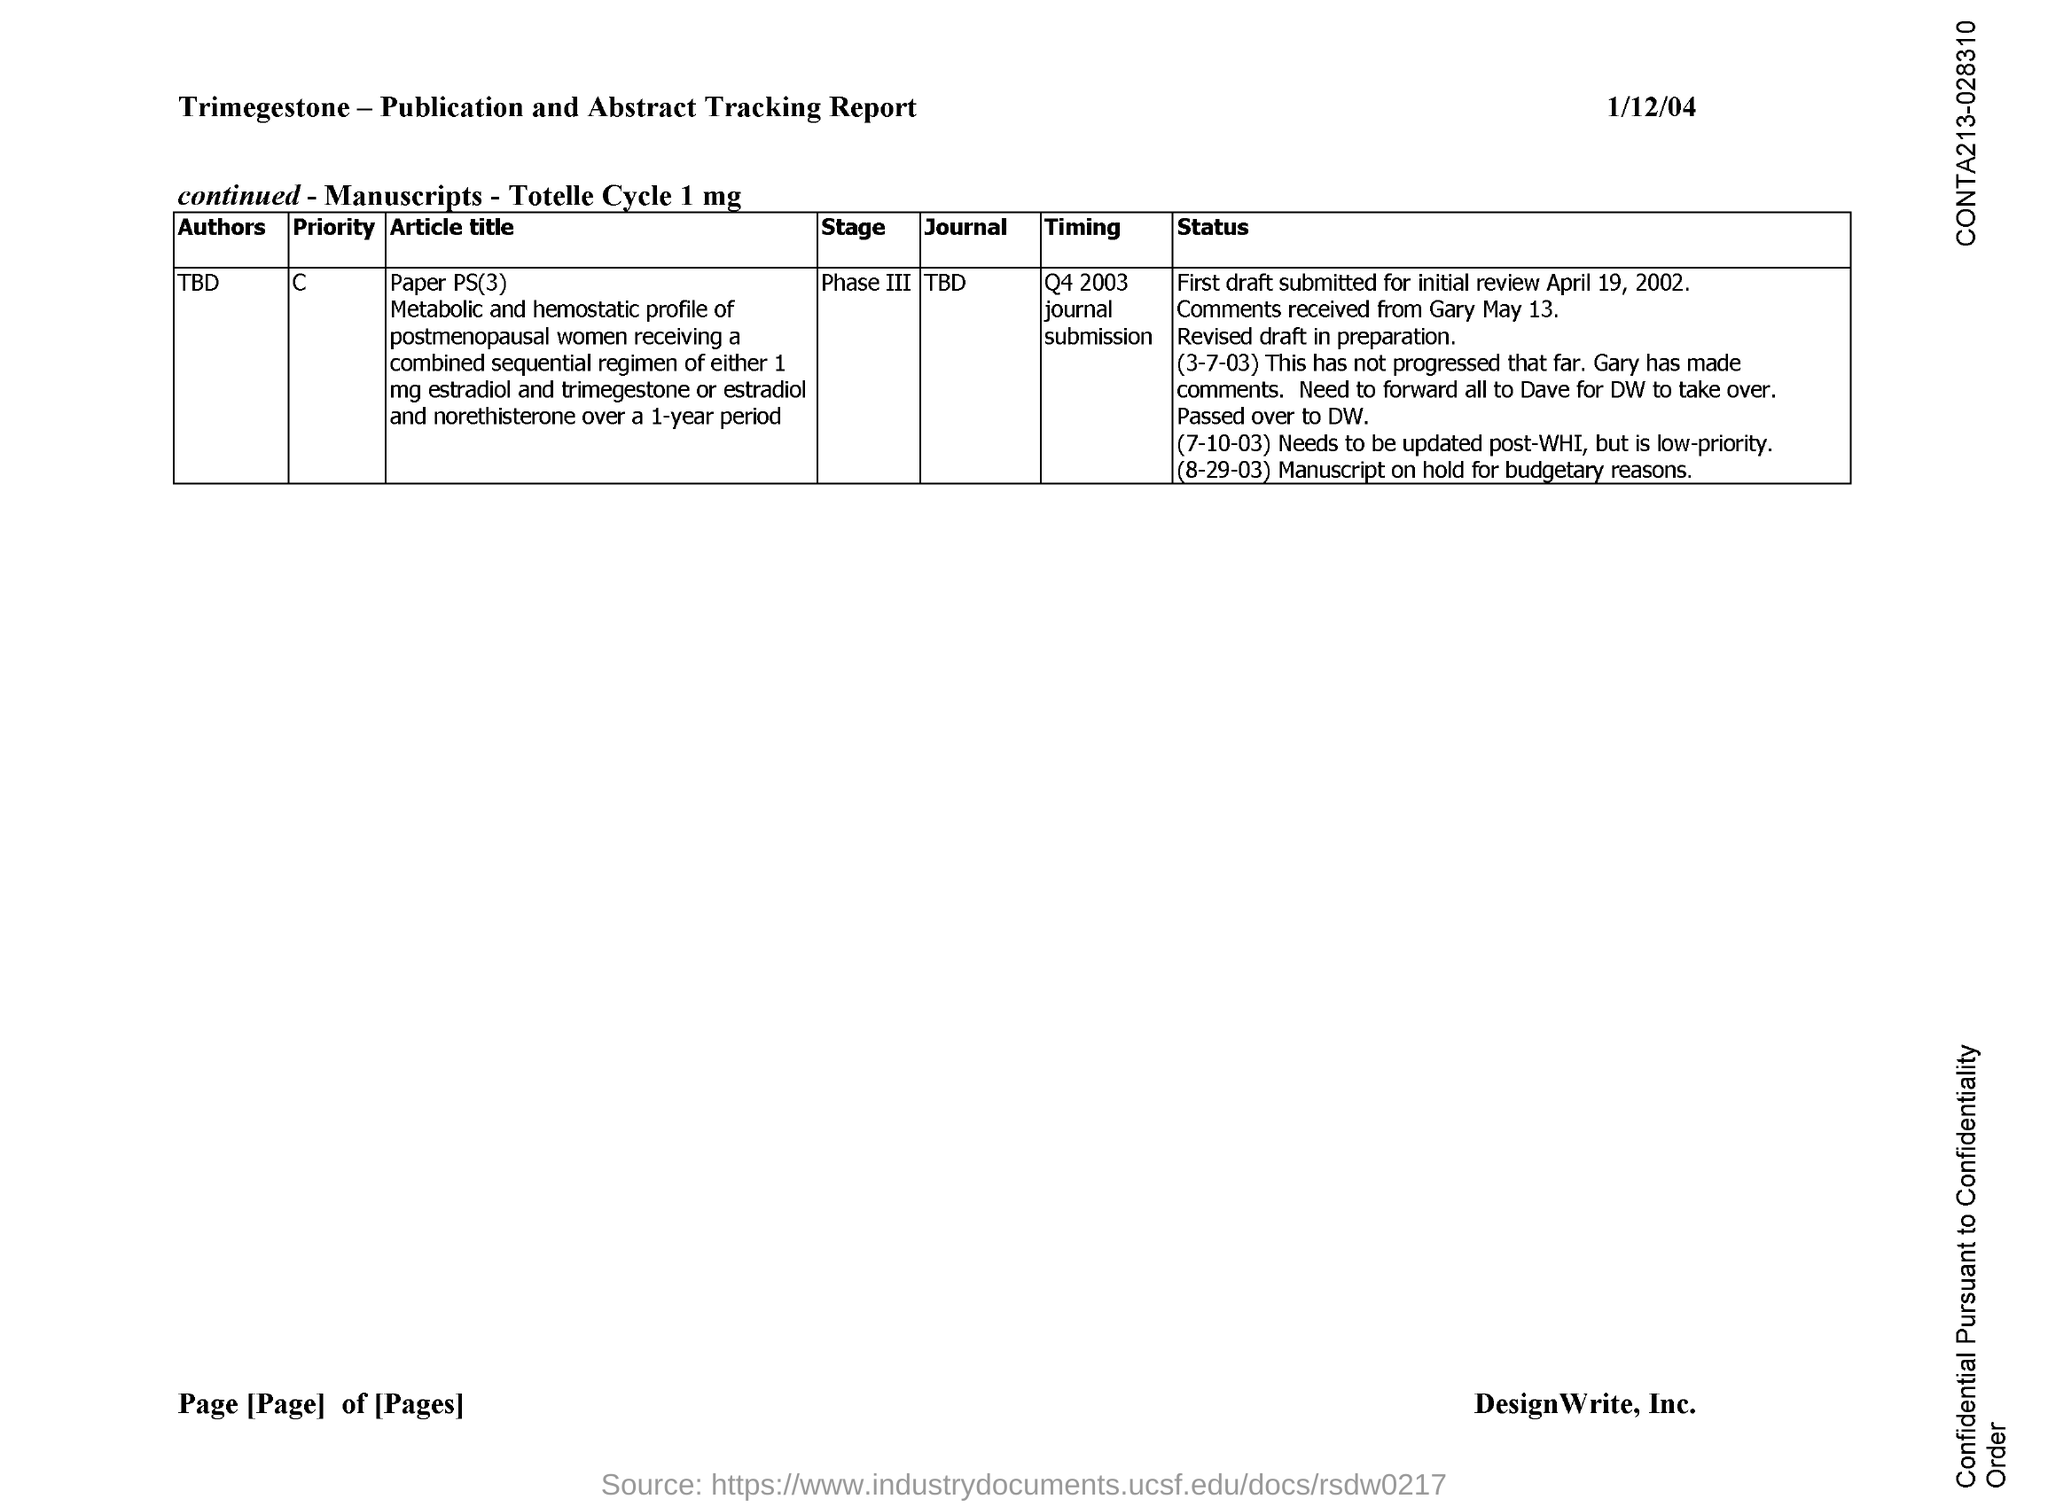What is the issued date of this document?
Provide a succinct answer. 1/12/04. What is the author name mentioned for Paper PS(3)?
Make the answer very short. TBD. What is the timing mentioned for Paper PS(3)?
Make the answer very short. Q4 2003. 